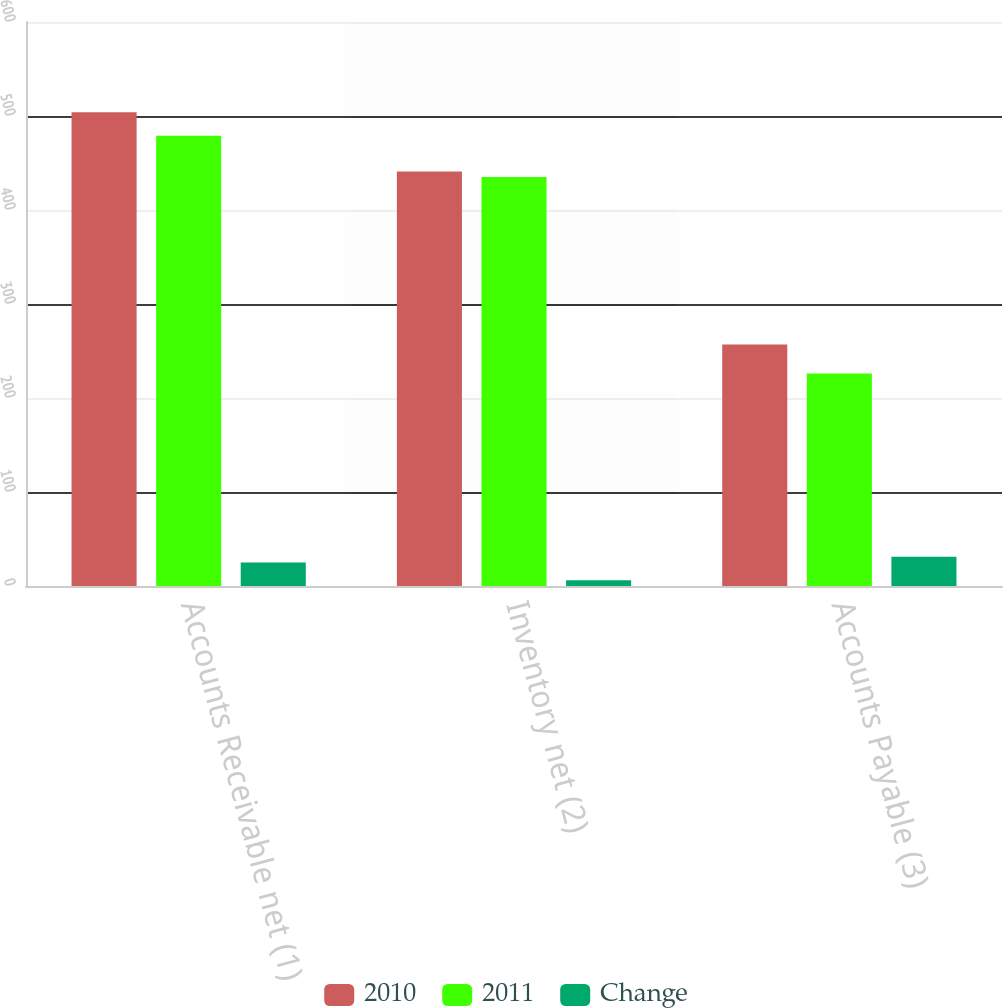<chart> <loc_0><loc_0><loc_500><loc_500><stacked_bar_chart><ecel><fcel>Accounts Receivable net (1)<fcel>Inventory net (2)<fcel>Accounts Payable (3)<nl><fcel>2010<fcel>504<fcel>441<fcel>257<nl><fcel>2011<fcel>479<fcel>435<fcel>226<nl><fcel>Change<fcel>25<fcel>6<fcel>31<nl></chart> 